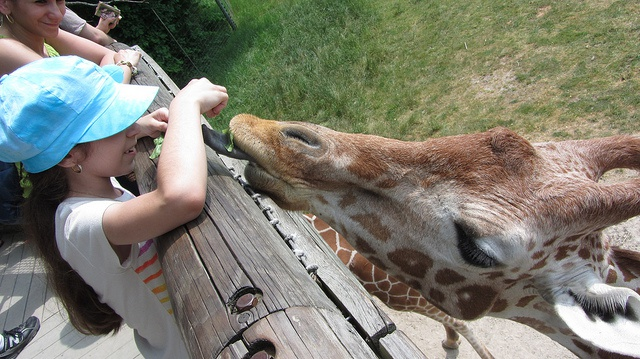Describe the objects in this image and their specific colors. I can see giraffe in maroon, gray, darkgray, and black tones, people in maroon, gray, white, black, and lightblue tones, people in maroon, brown, lightgray, and gray tones, giraffe in maroon and gray tones, and people in maroon, darkgray, gray, and lightgray tones in this image. 